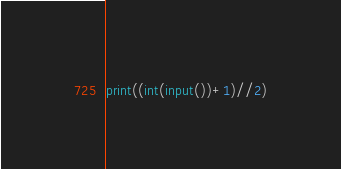<code> <loc_0><loc_0><loc_500><loc_500><_Python_>print((int(input())+1)//2)</code> 